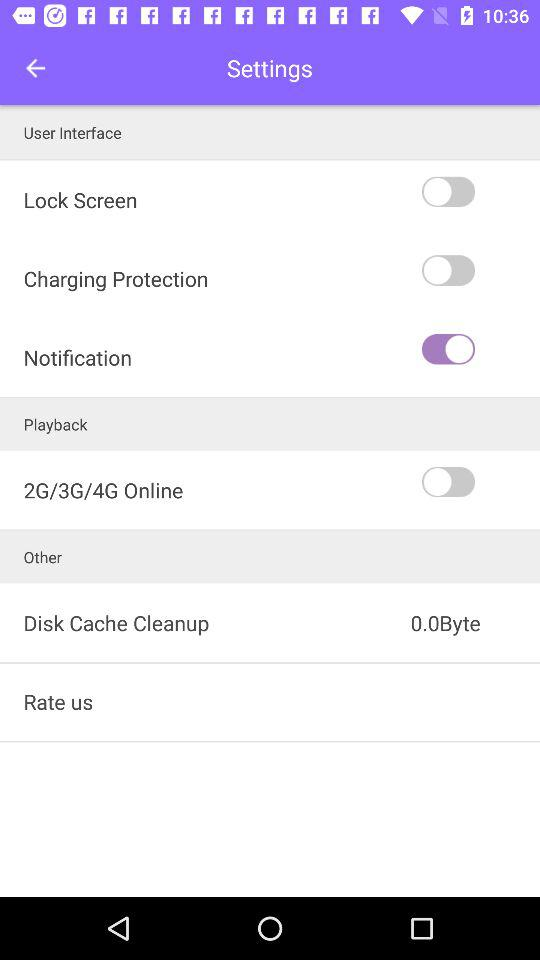What is the size of the disk cache cleanup? The size of the disk cache cleanup is 0.0 bytes. 